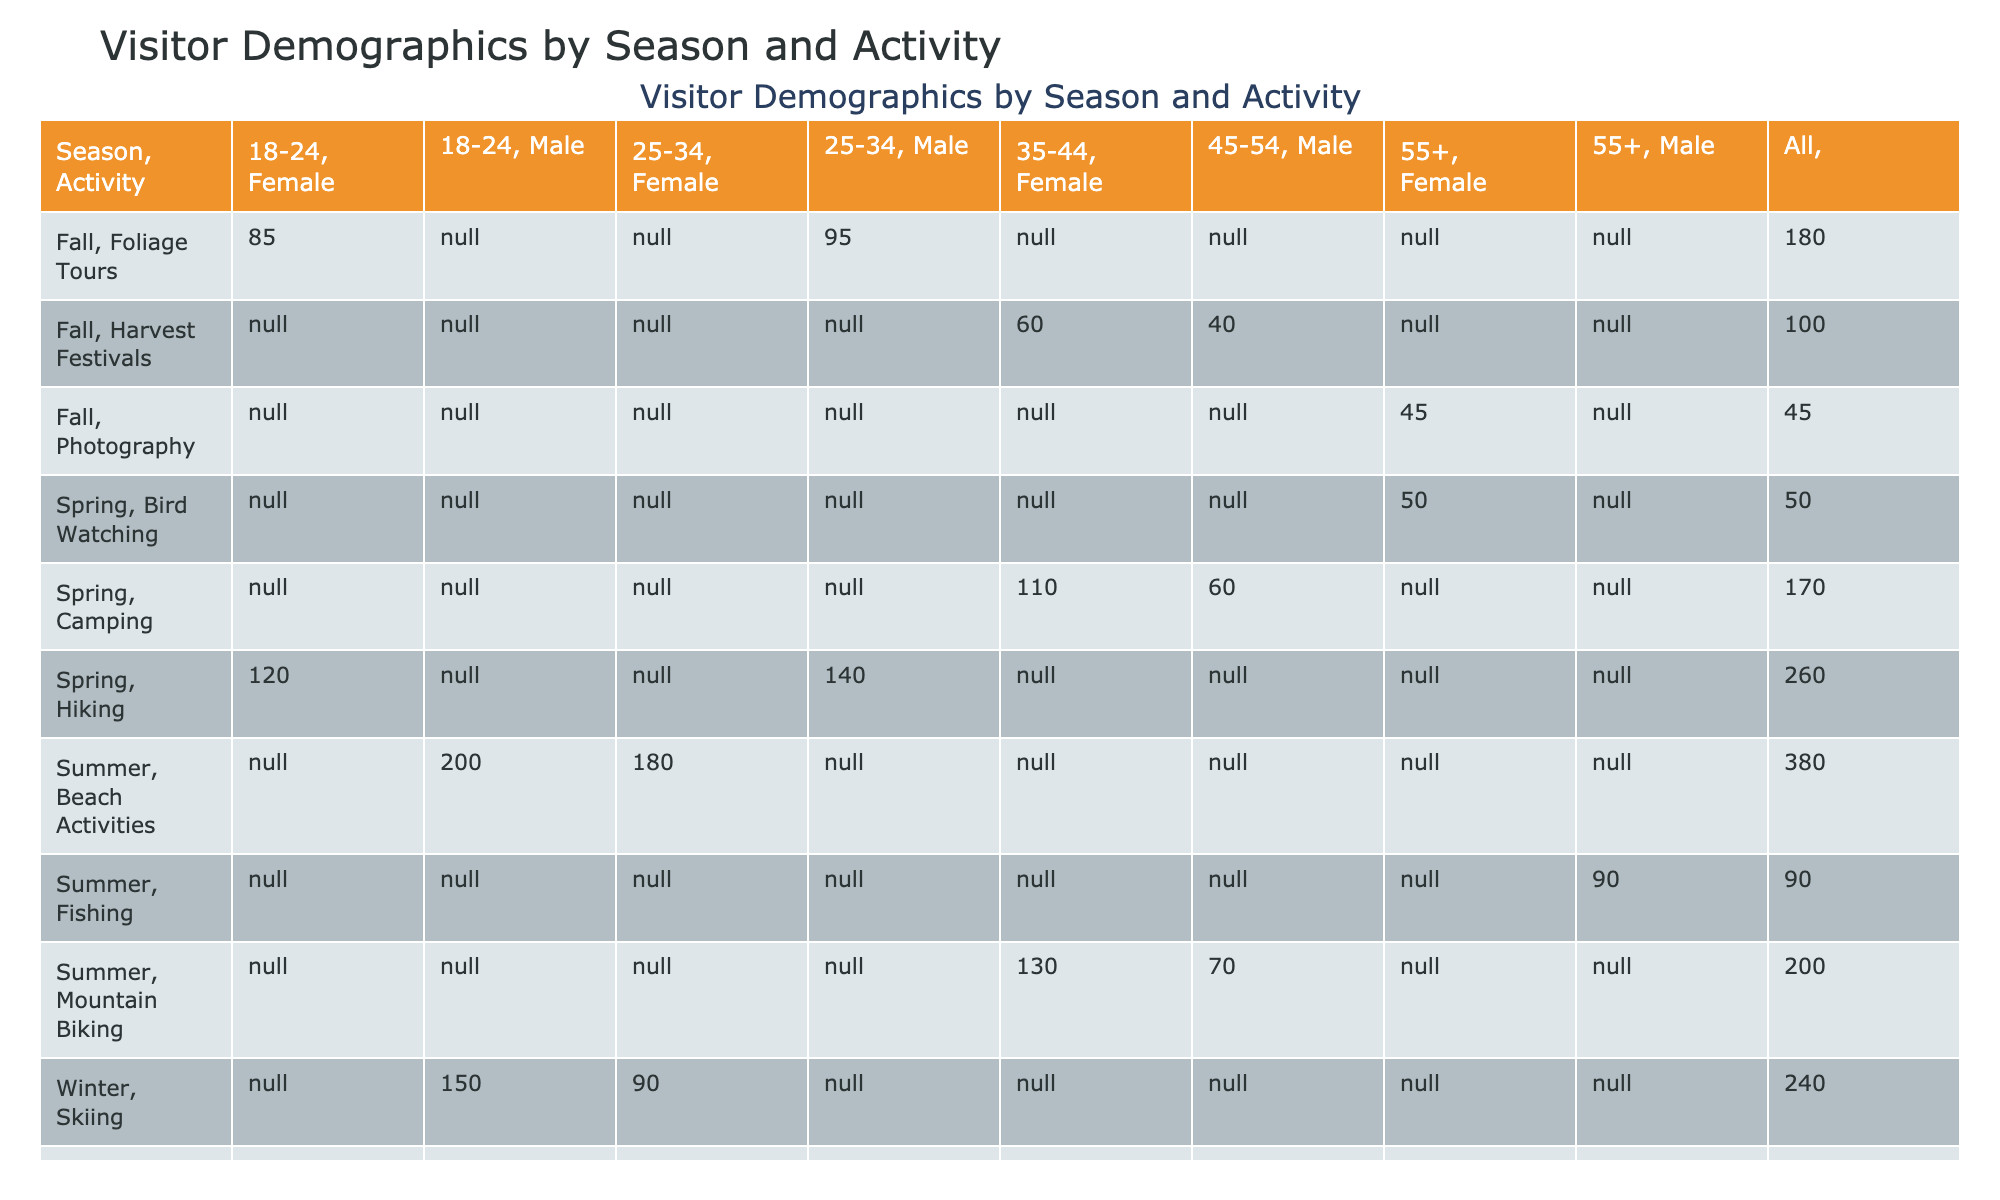What is the total number of visitors for Winter activities? To find the total number of visitors for Winter activities, I will sum the visitor counts for all activities listed under the Winter season: Skiing (150 + 90), Snowshoeing (70 + 40), and Winter Hiking (30). So, the total is 150 + 90 + 70 + 40 + 30 = 380.
Answer: 380 Which activity had the highest number of female visitors aged 35-44 in Spring? I need to look at the Spring season's activities and focus on females aged 35-44. The relevant activity is Camping with a visitor count of 110. This is the only activity listed for this age group in Spring, so it had the highest number of visitors.
Answer: Camping with 110 visitors Are there more male visitors aged 25-34 during Summer or Winter? In Summer, for the age group 25-34, there are Beach Activities with 180 male visitors. In Winter, for the same age group, there are Skiing with 90 male visitors. Since 180 is greater than 90, there are more male visitors in Summer.
Answer: Yes What is the difference in total visitor count between Beach Activities in Summer and the combined count of Skiing and Snowshoeing in Winter? First, I find the total for Beach Activities in Summer, which has 200 (18-24, Male) + 180 (25-34, Female) = 380. Then, for Winter, Skiing has 150 (18-24, Male) + 90 (25-34, Female) = 240 and Snowshoeing has 70 (35-44, Female) + 40 (45-54, Male) = 110, giving a combined total of 240 + 110 = 350. The difference is 380 - 350 = 30.
Answer: 30 What percentage of visitors in the Fall participated in Harvest Festivals? First, I need to sum the total number of visitors in Fall. The total is 85 (Foliage Tours, 18-24, Female) + 95 (Foliage Tours, 25-34, Male) + 60 (Harvest Festivals, 35-44, Female) + 40 (Harvest Festivals, 45-54, Male) + 45 (Photography, 55+, Female) = 325 visitors. The number of visitors for Harvest Festivals is 60 + 40 = 100. Now, to find the percentage: (100/325) * 100 = 30.77%.
Answer: 30.77% 